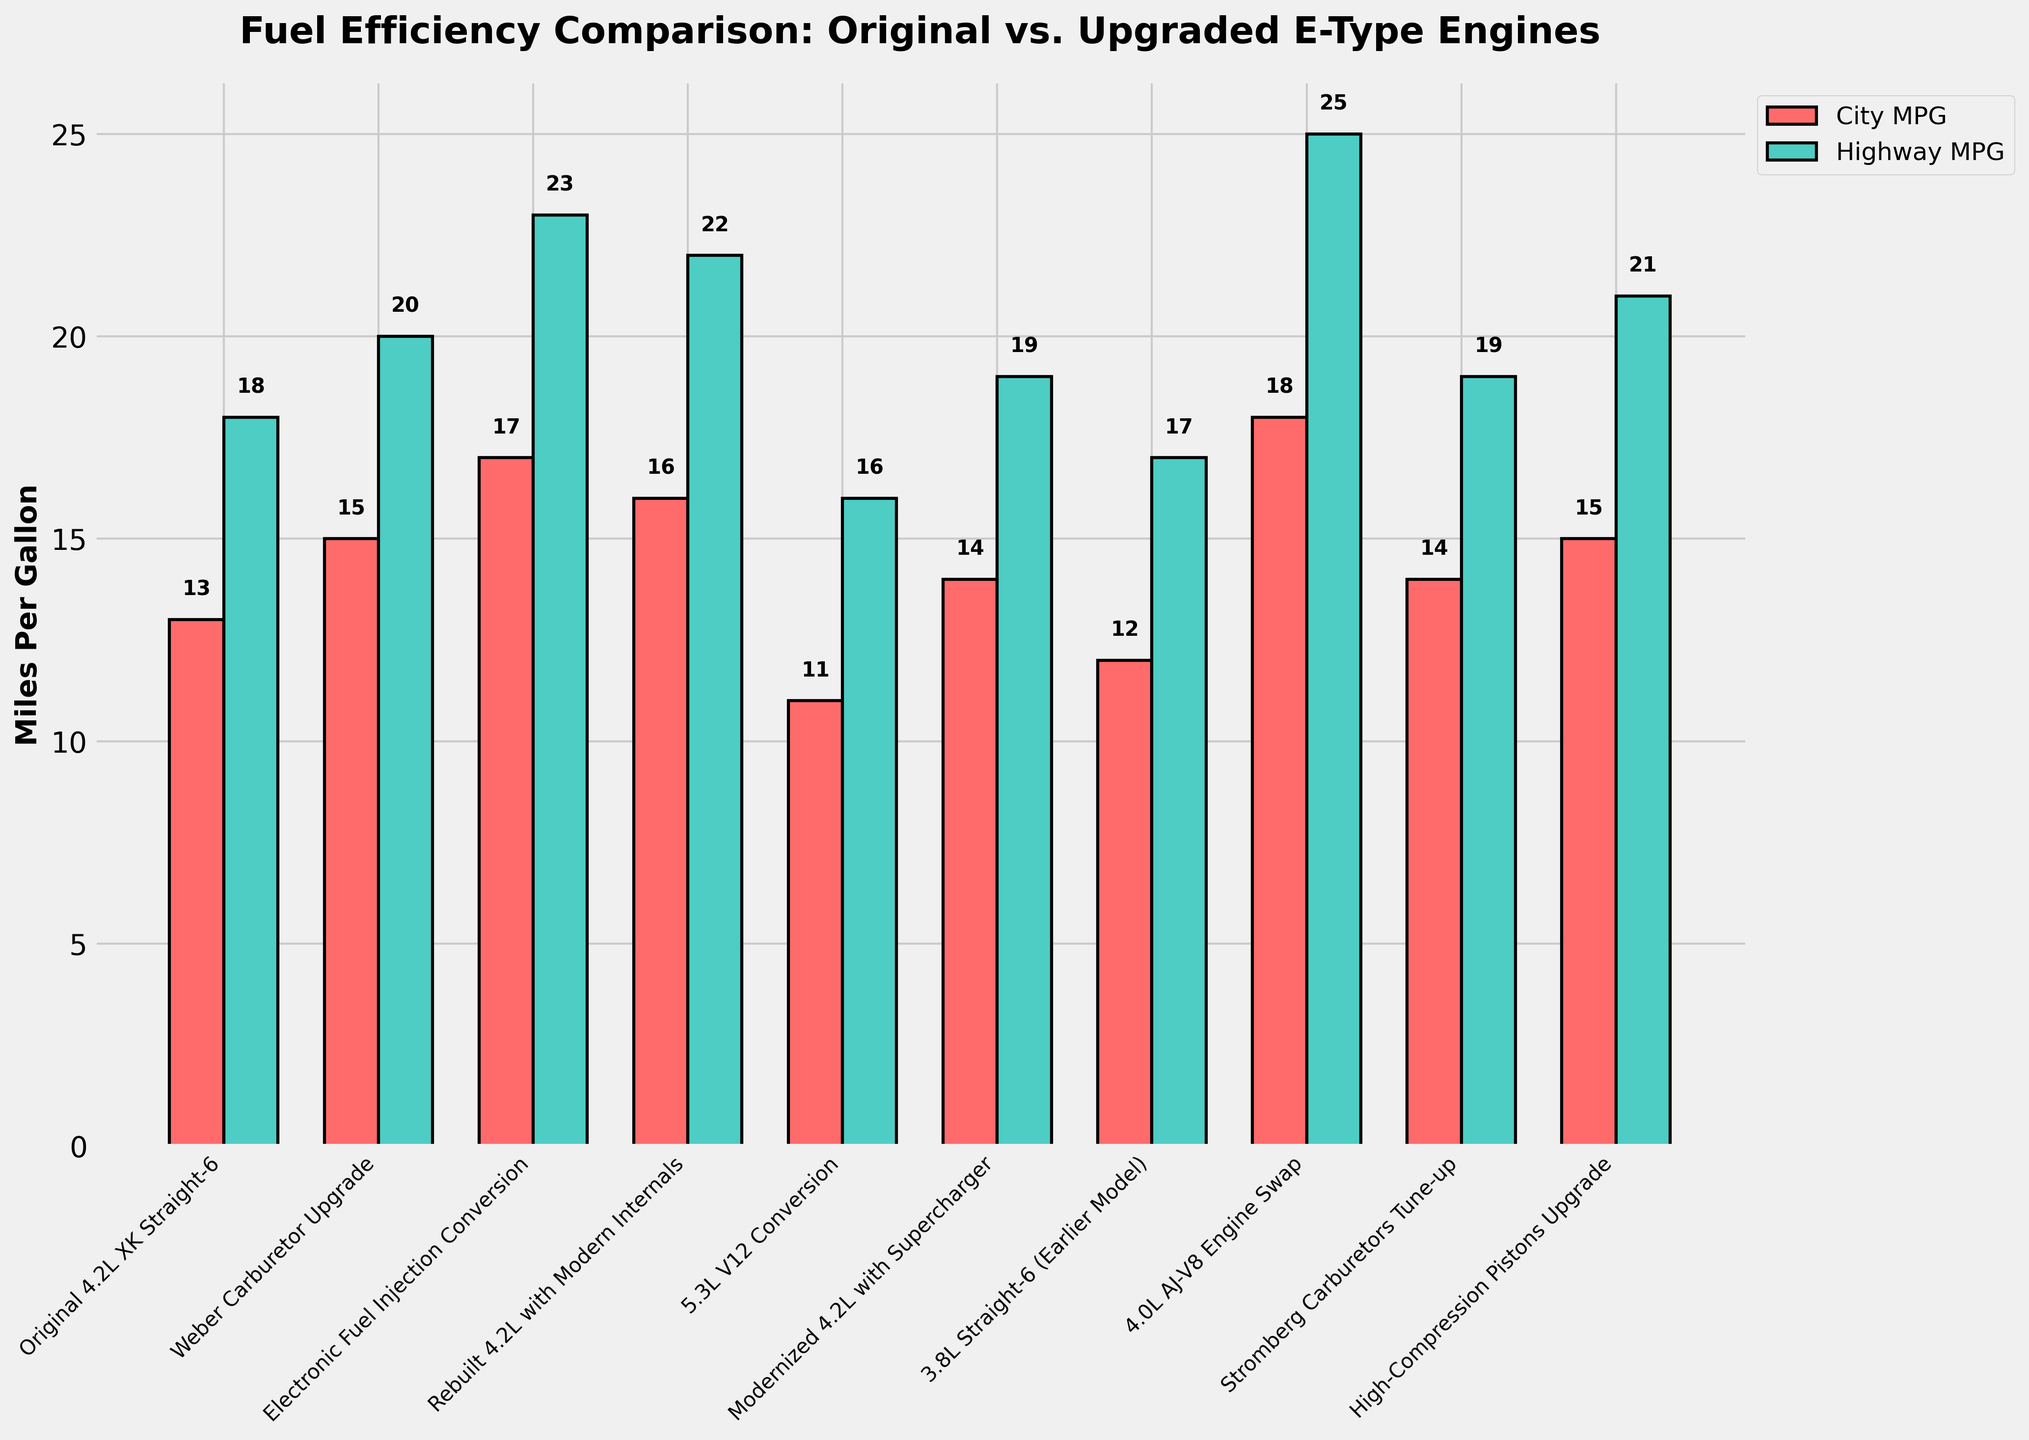Which engine configuration has the highest city MPG? Look for the tallest bar in the red series (City MPG) to identify the engine configuration with the maximum height.
Answer: 4.0L AJ-V8 Engine Swap What is the difference in highway MPG between the original engine and the electronic fuel injection conversion? Find the highway MPG for both configurations (18 MPG for the original, 23 MPG for the conversion) and subtract the original's value from the conversion's value: 23 - 18.
Answer: 5 Which upgrade yields the highest improvement in city MPG compared to the original engine? Compare each engine's city MPG with the original engine's city MPG (13 MPG). The highest improvement is seen in 4.0L AJ-V8 Engine Swap, which has 18 MPG (an improvement of 5 MPG).
Answer: 4.0L AJ-V8 Engine Swap How much lower is the city MPG of the 5.3L V12 conversion compared to the original 4.2L XK Straight-6? Subtract the city MPG of the 5.3L V12 conversion (11 MPG) from that of the original engine (13 MPG): 13 - 11.
Answer: 2 Which engine configuration has equal values for both city and highway MPG? Look for the bars where the red and green heights are the same. Both the Weber Carburetor Upgrade and Stromberg Carburetors Tune-up show equal city and highway MPG values of 14 and 19, respectively.
Answer: None What is the average highway MPG across all engine configurations? Sum all the highway MPG values (18 + 20 + 23 + 22 + 16 + 19 + 17 + 25 + 19 + 21 = 200) and divide by the number of configurations (10): 200 / 10.
Answer: 20 Which engine configuration shows the least difference between city and highway MPG? For each configuration, calculate the difference between highway MPG and city MPG, then find the smallest value. The smallest difference is 2 MPG for Weber Carburetor Upgrade and Stromberg Carburetors Tune-up, both having 14 MPG in the city and 19 MPG on the highway.
Answer: Weber Carburetor Upgrade and Stromberg Carburetors Tune-up Between the 5.3L V12 Conversion and Modernized 4.2L with Supercharger, which one has better fuel efficiency on the highway? Compare the highway MPG values of the 5.3L V12 Conversion (16 MPG) and Modernized 4.2L with Supercharger (19 MPG).
Answer: Modernized 4.2L with Supercharger By how much does the highway MPG of the High-Compression Pistons Upgrade exceed that of the original engine? Subtract the highway MPG of the original engine (18 MPG) from that of the High-Compression Pistons Upgrade (21 MPG): 21 - 18.
Answer: 3 What is the combined MPG (average of city and highway) of the rebuilt 4.2L with modern internals? Add the city MPG and highway MPG values (16 and 22) and then divide by 2: (16 + 22) / 2.
Answer: 19 